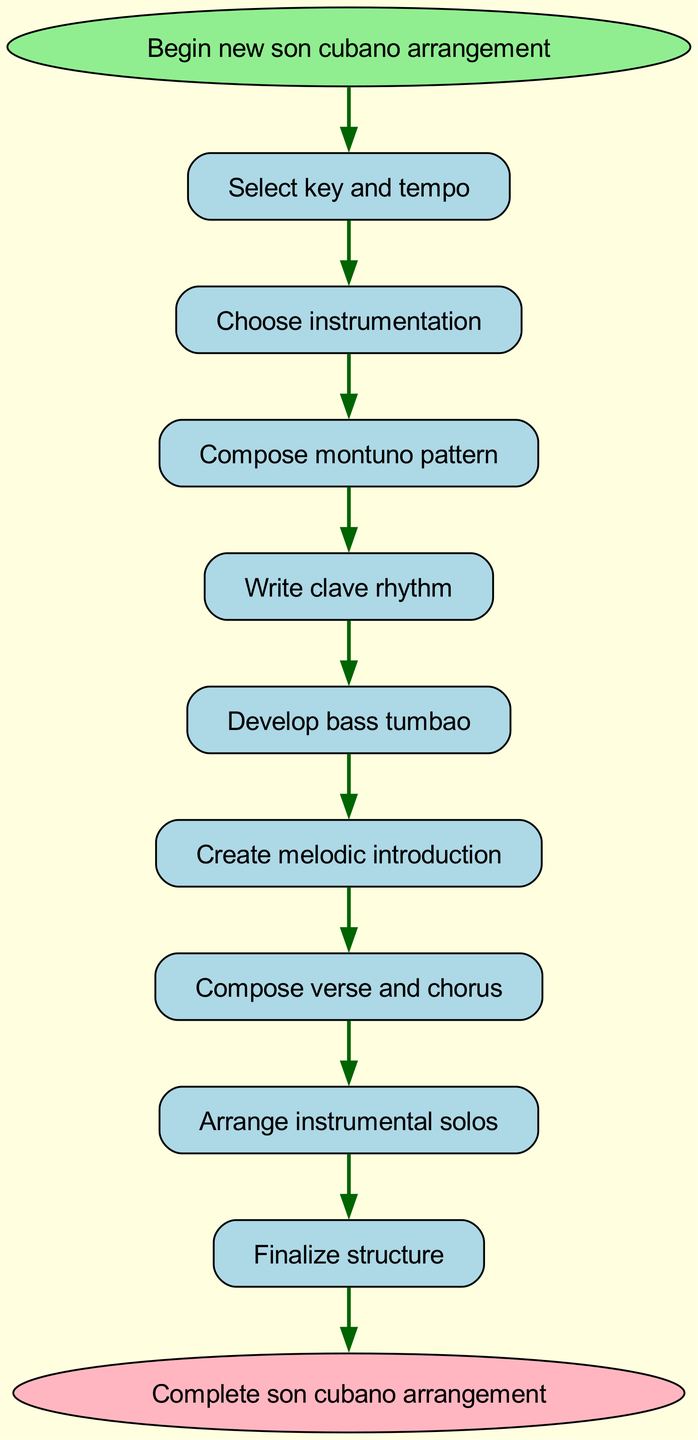What is the first step in composing a new son cubano arrangement? The diagram clearly indicates that the first step is to "Select key and tempo." This is the starting point from which all subsequent steps branch off.
Answer: Select key and tempo How many steps are there in the arrangement process? By counting the steps listed in the diagram (excluding the start and end nodes), there are nine distinct steps involved in the process.
Answer: Nine What is the last step before the finalization? "Arrange instrumental solos" is the last step listed before reaching "Finalize structure," indicating it is the final preparatory step before completion.
Answer: Arrange instrumental solos Which step comes after "Compose verse and chorus"? The flow clearly indicates that after "Compose verse and chorus," the next step is "Arrange instrumental solos." This shows the direct progression in the arrangement process.
Answer: Arrange instrumental solos If the instrumentation is missing, which step should be revisited? Based on the flow, "Choose instrumentation" is the step that occurs immediately after "Select key and tempo." If instrumentation is not properly addressed, this is the step that should be revisited.
Answer: Choose instrumentation How many edges are there in total in the diagram? The edges represent the directional flow from one step to another. There are a total of nine edges connecting the ten nodes (including start and end), as each step leads to the next.
Answer: Nine What are the key elements leading towards the final step? The elements leading to the final step "Complete son cubano arrangement" include: "Finalize structure" and prior steps: "Arrange instrumental solos", "Compose verse and chorus", and so on. These steps highlight a progressive buildup to completion.
Answer: Finalize structure, Arrange instrumental solos, Compose verse and chorus What follows the "Write clave rhythm" step? According to the flow, after "Write clave rhythm," the next step is "Develop bass tumbao." This connection indicates the logical sequence in the composing process.
Answer: Develop bass tumbao What type of diagram is this? This visualization is a flow chart, illustrating a sequence of steps within the function of composing a new son cubano arrangement. A flow chart typically organizes processes in an easily understandable way.
Answer: Flow chart 